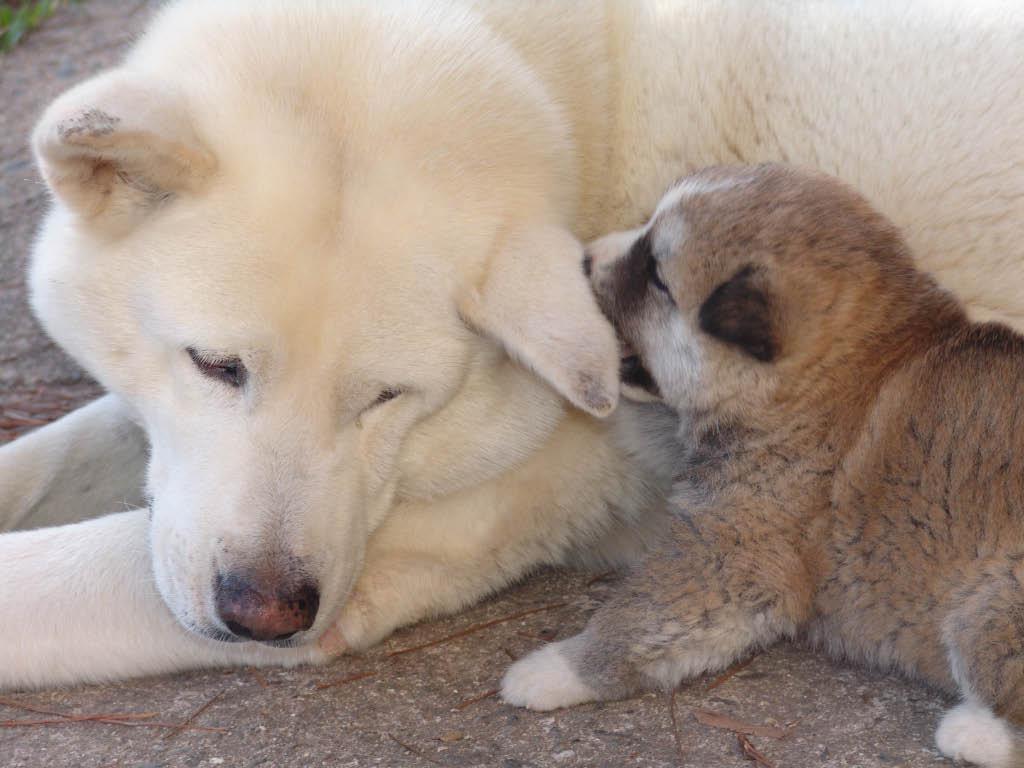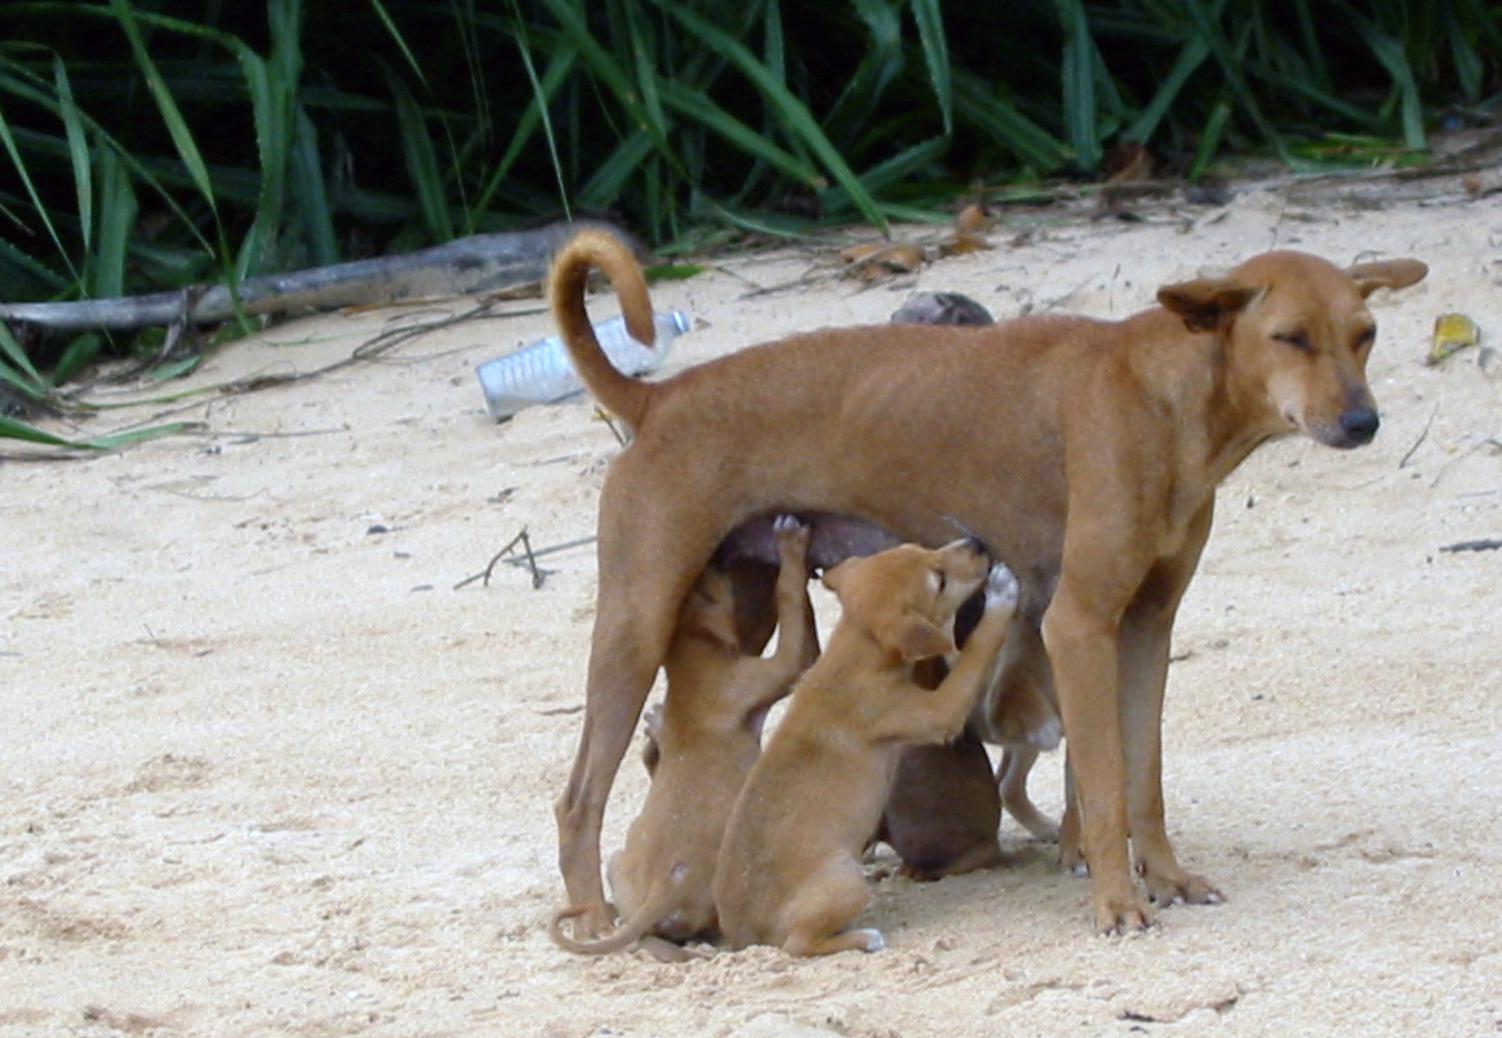The first image is the image on the left, the second image is the image on the right. Considering the images on both sides, is "Some of the animals in the image on the left are lying on the green grass." valid? Answer yes or no. No. The first image is the image on the left, the second image is the image on the right. Assess this claim about the two images: "Each image includes canine pups, and at least one image also includes at least one adult dog.". Correct or not? Answer yes or no. Yes. 